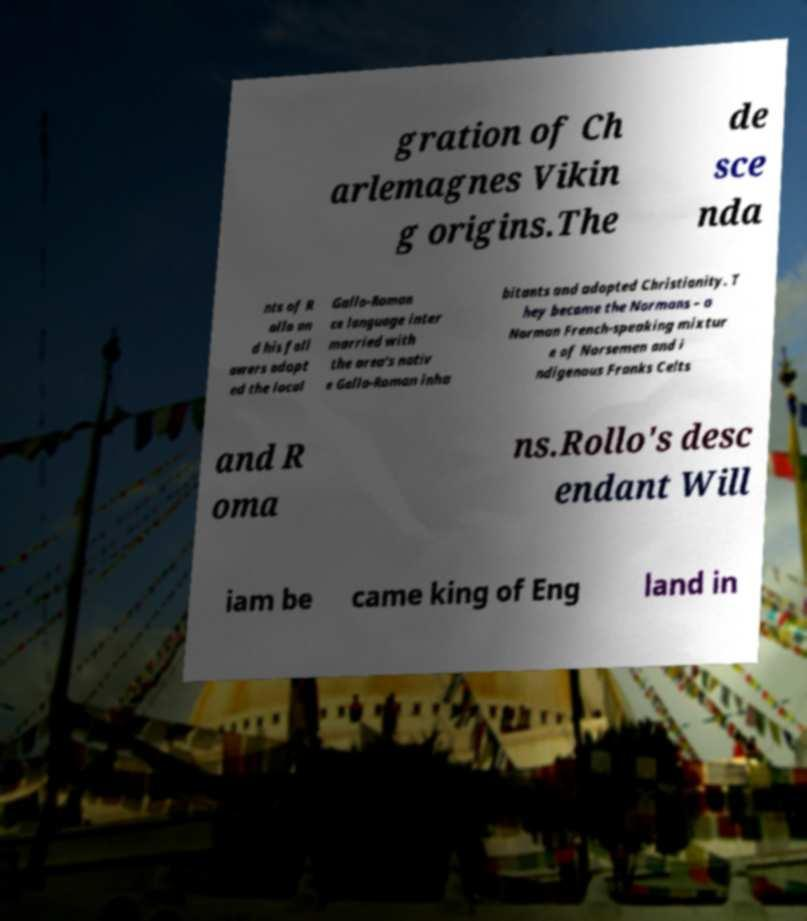Can you accurately transcribe the text from the provided image for me? gration of Ch arlemagnes Vikin g origins.The de sce nda nts of R ollo an d his foll owers adopt ed the local Gallo-Roman ce language inter married with the area's nativ e Gallo-Roman inha bitants and adopted Christianity. T hey became the Normans – a Norman French-speaking mixtur e of Norsemen and i ndigenous Franks Celts and R oma ns.Rollo's desc endant Will iam be came king of Eng land in 